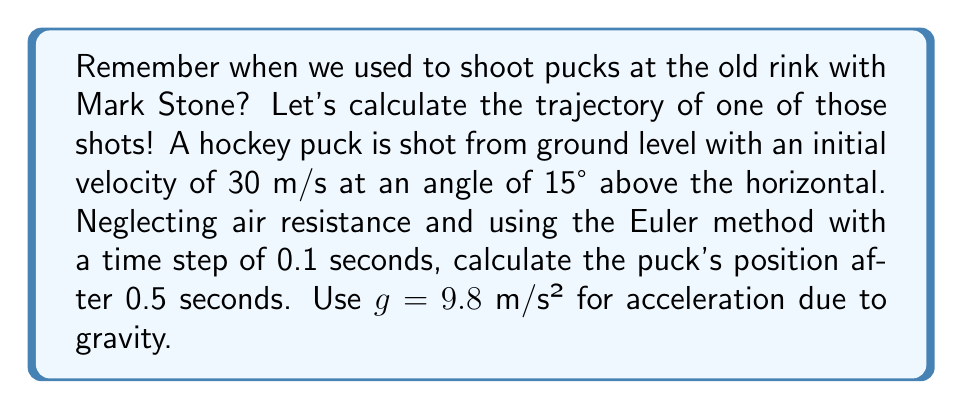Give your solution to this math problem. To solve this problem, we'll use the Euler method to numerically approximate the trajectory of the hockey puck. Let's break it down step-by-step:

1) First, let's define our initial conditions:
   $x_0 = 0$ m (initial x-position)
   $y_0 = 0$ m (initial y-position)
   $v_0 = 30$ m/s (initial velocity)
   $\theta = 15°$ (angle of launch)
   $\Delta t = 0.1$ s (time step)
   $t_{final} = 0.5$ s (time we're interested in)

2) We need to decompose the initial velocity into x and y components:
   $v_{x0} = v_0 \cos(\theta) = 30 \cos(15°) \approx 28.98$ m/s
   $v_{y0} = v_0 \sin(\theta) = 30 \sin(15°) \approx 7.76$ m/s

3) The Euler method uses the following equations:
   $x_{n+1} = x_n + v_{xn} \Delta t$
   $y_{n+1} = y_n + v_{yn} \Delta t$
   $v_{xn+1} = v_{xn}$ (constant in x-direction)
   $v_{yn+1} = v_{yn} - g \Delta t$

4) Let's calculate for each time step:

   At t = 0 s:
   $x_0 = 0$ m, $y_0 = 0$ m, $v_{x0} = 28.98$ m/s, $v_{y0} = 7.76$ m/s

   At t = 0.1 s:
   $x_1 = 0 + 28.98 * 0.1 = 2.898$ m
   $y_1 = 0 + 7.76 * 0.1 = 0.776$ m
   $v_{x1} = 28.98$ m/s
   $v_{y1} = 7.76 - 9.8 * 0.1 = 6.78$ m/s

   At t = 0.2 s:
   $x_2 = 2.898 + 28.98 * 0.1 = 5.796$ m
   $y_2 = 0.776 + 6.78 * 0.1 = 1.454$ m
   $v_{x2} = 28.98$ m/s
   $v_{y2} = 6.78 - 9.8 * 0.1 = 5.80$ m/s

   At t = 0.3 s:
   $x_3 = 5.796 + 28.98 * 0.1 = 8.694$ m
   $y_3 = 1.454 + 5.80 * 0.1 = 2.034$ m
   $v_{x3} = 28.98$ m/s
   $v_{y3} = 5.80 - 9.8 * 0.1 = 4.82$ m/s

   At t = 0.4 s:
   $x_4 = 8.694 + 28.98 * 0.1 = 11.592$ m
   $y_4 = 2.034 + 4.82 * 0.1 = 2.516$ m
   $v_{x4} = 28.98$ m/s
   $v_{y4} = 4.82 - 9.8 * 0.1 = 3.84$ m/s

   At t = 0.5 s:
   $x_5 = 11.592 + 28.98 * 0.1 = 14.490$ m
   $y_5 = 2.516 + 3.84 * 0.1 = 2.900$ m

5) Therefore, after 0.5 seconds, the puck's position is approximately (14.490 m, 2.900 m).
Answer: The position of the hockey puck after 0.5 seconds is approximately (14.490 m, 2.900 m). 